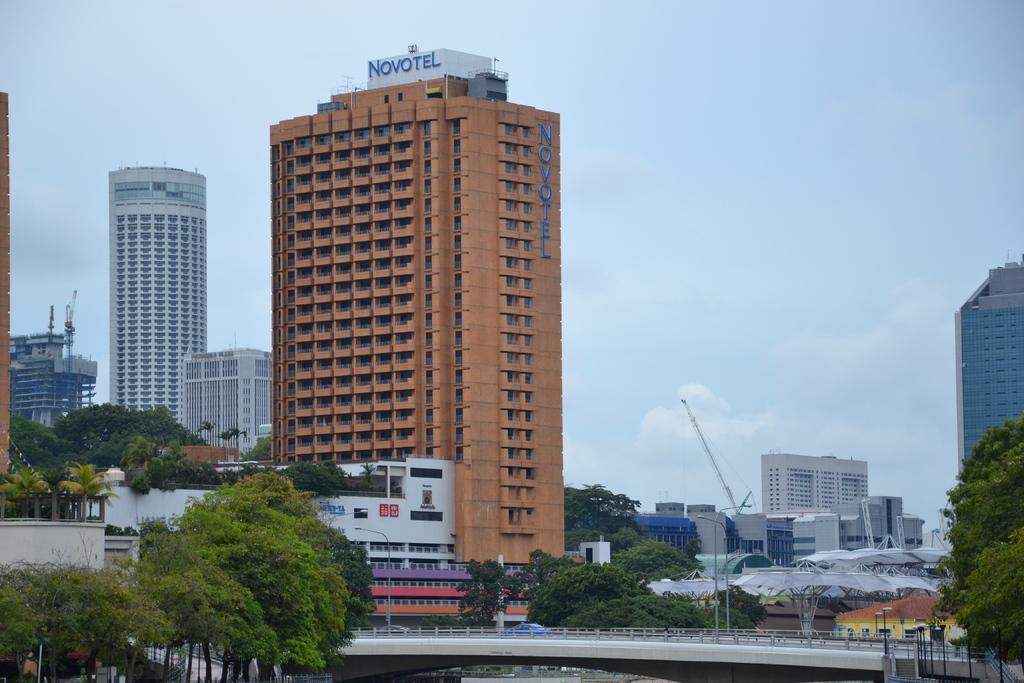Can you describe this image briefly? In the foreground of the image we can see a bridge. To the left side of the image we can see group of trees ,buildings. To the right side of the image we can see a group of sheds,a crane and in background we can see sky. 